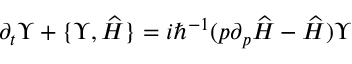<formula> <loc_0><loc_0><loc_500><loc_500>\partial _ { t } \Upsilon + \{ \Upsilon , \widehat { H } \} = i \hbar { ^ } { - 1 } ( p \partial _ { p } \widehat { H } - \widehat { H } ) \Upsilon</formula> 